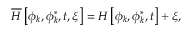Convert formula to latex. <formula><loc_0><loc_0><loc_500><loc_500>\overline { H } \left [ \phi _ { k } , \phi _ { k } ^ { * } , t , \xi \right ] = H \left [ \phi _ { k } , \phi _ { k } ^ { * } , t \right ] + \xi ,</formula> 